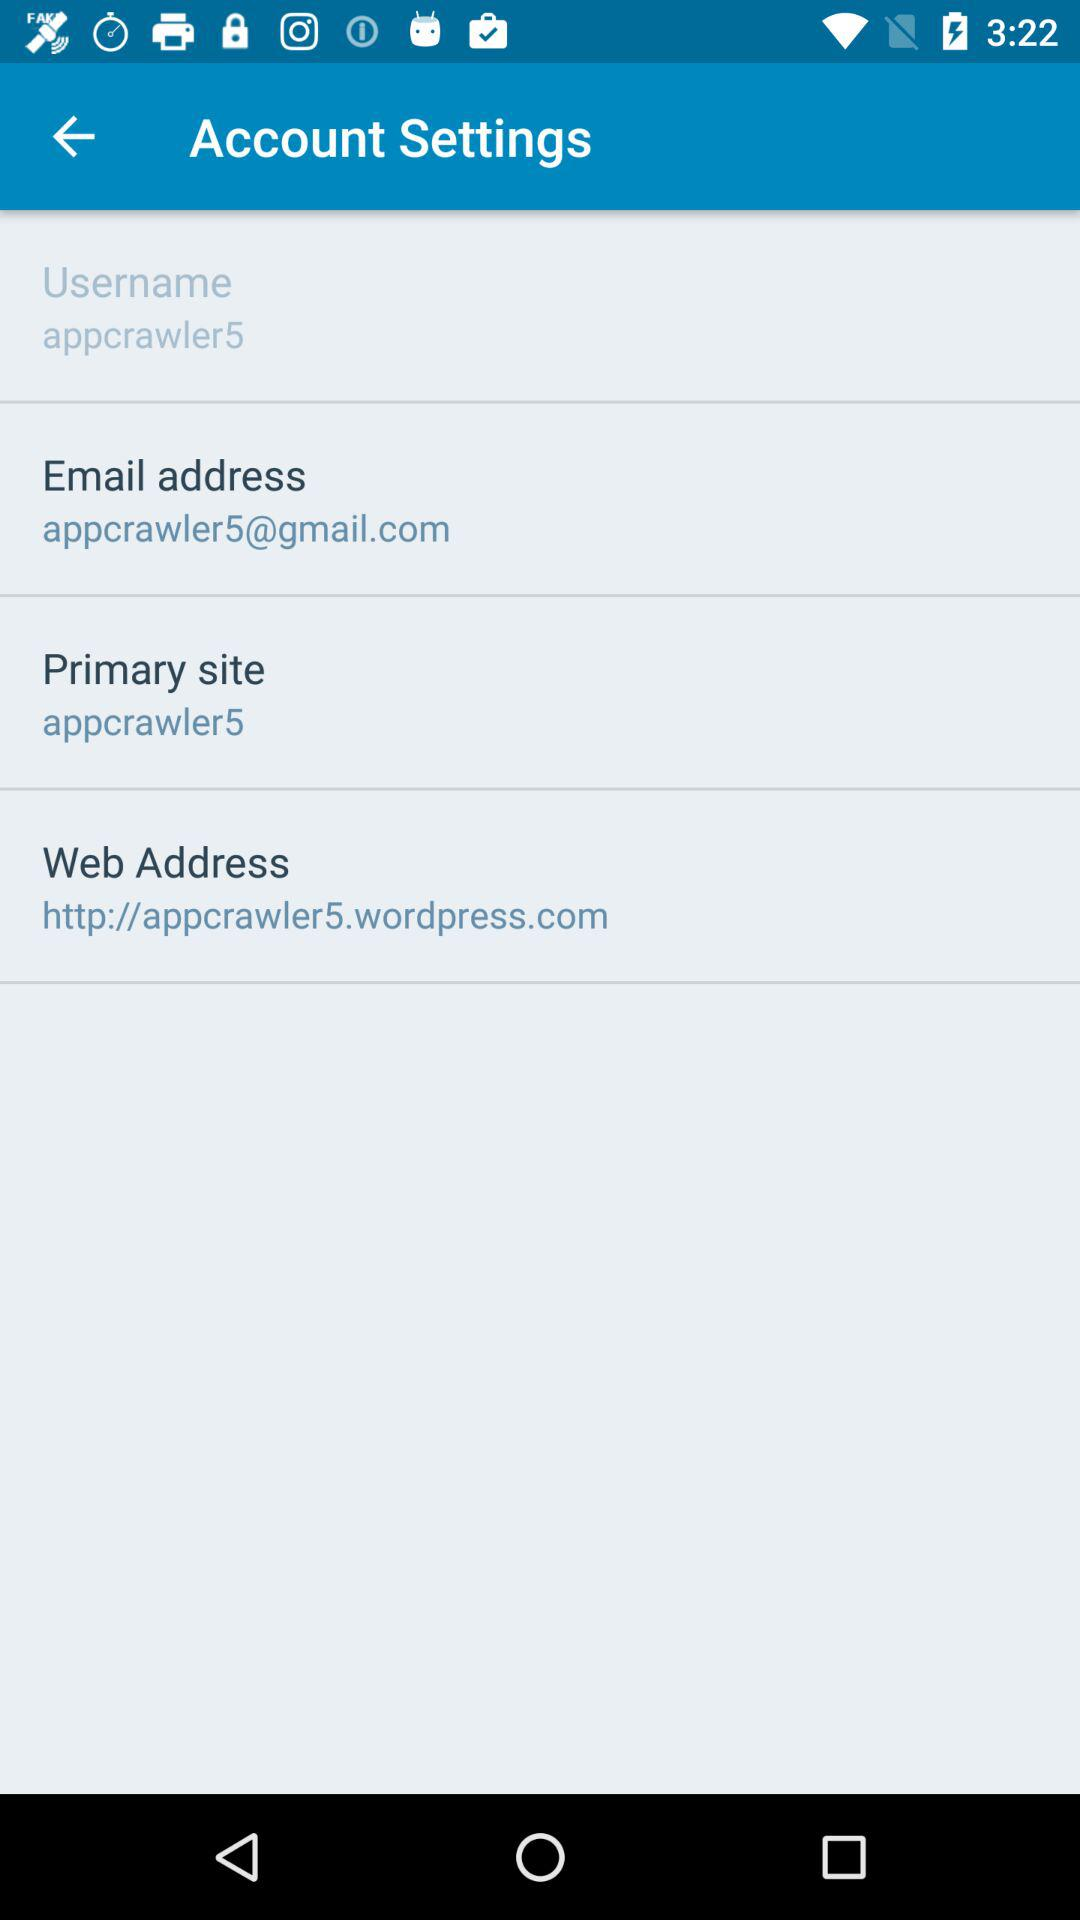What's the primary site? The primary site is appcrawler5. 